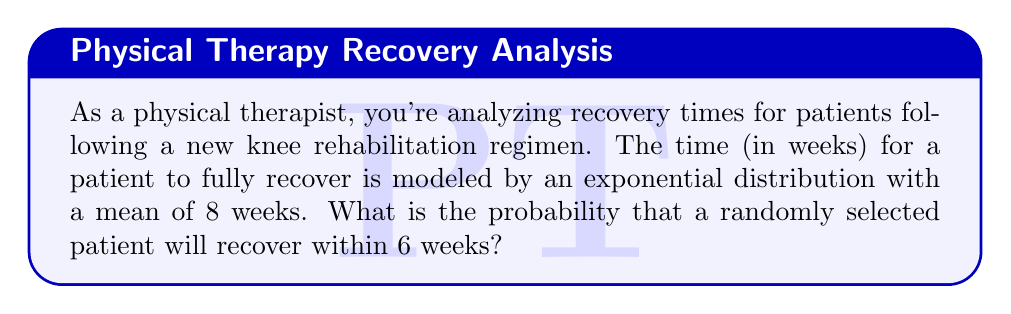Solve this math problem. Let's approach this step-by-step:

1) The exponential distribution is given by the probability density function:
   $$f(x) = \lambda e^{-\lambda x}$$
   where $\lambda$ is the rate parameter.

2) We're given that the mean recovery time is 8 weeks. For an exponential distribution, the mean is equal to $\frac{1}{\lambda}$. So:
   $$\frac{1}{\lambda} = 8$$
   $$\lambda = \frac{1}{8}$$

3) The cumulative distribution function (CDF) of an exponential distribution gives the probability that the recovery time is less than or equal to a given value. It's given by:
   $$F(x) = 1 - e^{-\lambda x}$$

4) We want to find the probability of recovery within 6 weeks, so we'll use $x = 6$:
   $$P(X \leq 6) = 1 - e^{-\frac{1}{8} \cdot 6}$$

5) Let's calculate this:
   $$P(X \leq 6) = 1 - e^{-\frac{3}{4}}$$
   $$= 1 - e^{-0.75}$$
   $$= 1 - 0.4724$$
   $$= 0.5276$$

6) Converting to a percentage:
   $$0.5276 \cdot 100\% = 52.76\%$$

Thus, there is approximately a 52.76% chance that a randomly selected patient will recover within 6 weeks.
Answer: 52.76% 